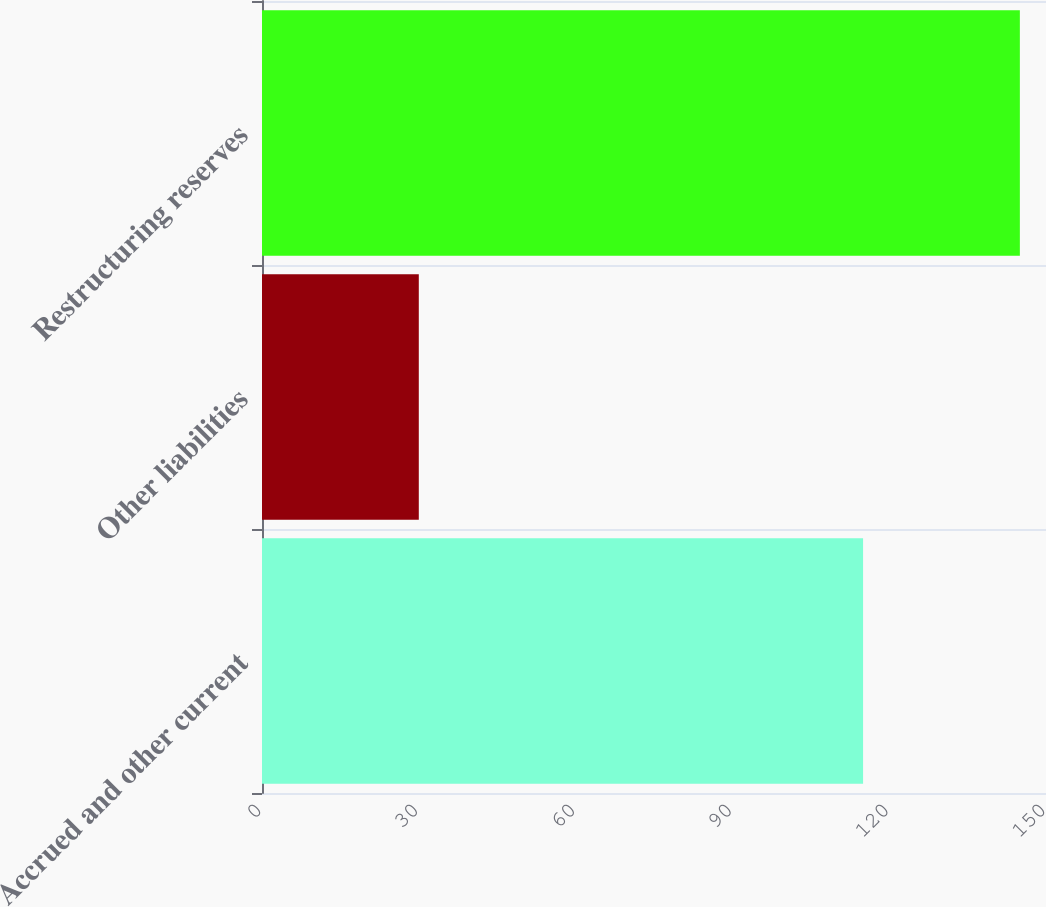Convert chart to OTSL. <chart><loc_0><loc_0><loc_500><loc_500><bar_chart><fcel>Accrued and other current<fcel>Other liabilities<fcel>Restructuring reserves<nl><fcel>115<fcel>30<fcel>145<nl></chart> 